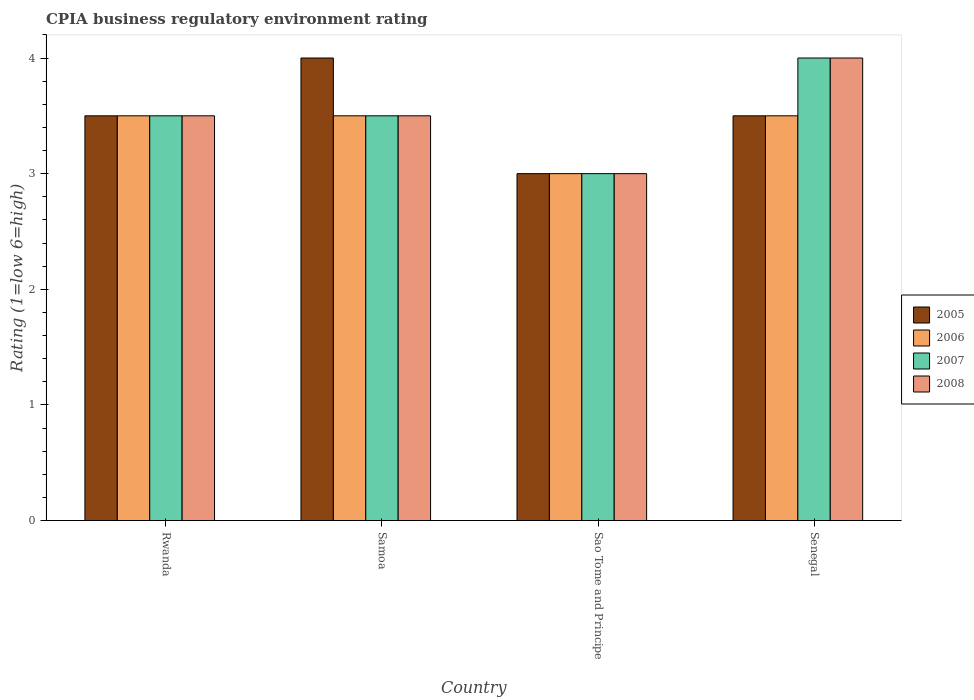How many groups of bars are there?
Your answer should be very brief. 4. What is the label of the 1st group of bars from the left?
Your response must be concise. Rwanda. Across all countries, what is the minimum CPIA rating in 2008?
Your response must be concise. 3. In which country was the CPIA rating in 2006 maximum?
Your answer should be very brief. Rwanda. In which country was the CPIA rating in 2007 minimum?
Your response must be concise. Sao Tome and Principe. What is the total CPIA rating in 2008 in the graph?
Provide a succinct answer. 14. What is the difference between the CPIA rating in 2007 in Sao Tome and Principe and the CPIA rating in 2008 in Samoa?
Provide a short and direct response. -0.5. What is the average CPIA rating in 2006 per country?
Keep it short and to the point. 3.38. What is the difference between the CPIA rating of/in 2007 and CPIA rating of/in 2005 in Senegal?
Give a very brief answer. 0.5. What is the difference between the highest and the second highest CPIA rating in 2005?
Offer a very short reply. -0.5. In how many countries, is the CPIA rating in 2008 greater than the average CPIA rating in 2008 taken over all countries?
Offer a terse response. 1. What does the 4th bar from the right in Sao Tome and Principe represents?
Ensure brevity in your answer.  2005. What is the difference between two consecutive major ticks on the Y-axis?
Your answer should be very brief. 1. Are the values on the major ticks of Y-axis written in scientific E-notation?
Keep it short and to the point. No. Where does the legend appear in the graph?
Your answer should be compact. Center right. How are the legend labels stacked?
Provide a succinct answer. Vertical. What is the title of the graph?
Ensure brevity in your answer.  CPIA business regulatory environment rating. Does "1995" appear as one of the legend labels in the graph?
Your answer should be compact. No. What is the Rating (1=low 6=high) in 2006 in Rwanda?
Your answer should be compact. 3.5. What is the Rating (1=low 6=high) of 2006 in Samoa?
Ensure brevity in your answer.  3.5. What is the Rating (1=low 6=high) in 2007 in Samoa?
Keep it short and to the point. 3.5. What is the Rating (1=low 6=high) of 2008 in Samoa?
Your answer should be very brief. 3.5. What is the Rating (1=low 6=high) of 2006 in Sao Tome and Principe?
Give a very brief answer. 3. What is the Rating (1=low 6=high) of 2007 in Sao Tome and Principe?
Offer a terse response. 3. What is the Rating (1=low 6=high) in 2006 in Senegal?
Give a very brief answer. 3.5. What is the Rating (1=low 6=high) of 2007 in Senegal?
Your answer should be compact. 4. What is the Rating (1=low 6=high) in 2008 in Senegal?
Offer a terse response. 4. Across all countries, what is the maximum Rating (1=low 6=high) in 2008?
Make the answer very short. 4. Across all countries, what is the minimum Rating (1=low 6=high) in 2006?
Provide a short and direct response. 3. Across all countries, what is the minimum Rating (1=low 6=high) in 2007?
Ensure brevity in your answer.  3. What is the total Rating (1=low 6=high) of 2005 in the graph?
Ensure brevity in your answer.  14. What is the total Rating (1=low 6=high) of 2006 in the graph?
Your answer should be compact. 13.5. What is the total Rating (1=low 6=high) of 2008 in the graph?
Offer a very short reply. 14. What is the difference between the Rating (1=low 6=high) in 2006 in Rwanda and that in Sao Tome and Principe?
Offer a very short reply. 0.5. What is the difference between the Rating (1=low 6=high) in 2008 in Rwanda and that in Sao Tome and Principe?
Your answer should be compact. 0.5. What is the difference between the Rating (1=low 6=high) in 2005 in Rwanda and that in Senegal?
Make the answer very short. 0. What is the difference between the Rating (1=low 6=high) in 2006 in Rwanda and that in Senegal?
Provide a short and direct response. 0. What is the difference between the Rating (1=low 6=high) in 2005 in Samoa and that in Sao Tome and Principe?
Your response must be concise. 1. What is the difference between the Rating (1=low 6=high) in 2007 in Samoa and that in Sao Tome and Principe?
Give a very brief answer. 0.5. What is the difference between the Rating (1=low 6=high) of 2008 in Samoa and that in Sao Tome and Principe?
Make the answer very short. 0.5. What is the difference between the Rating (1=low 6=high) of 2005 in Samoa and that in Senegal?
Offer a very short reply. 0.5. What is the difference between the Rating (1=low 6=high) of 2006 in Samoa and that in Senegal?
Ensure brevity in your answer.  0. What is the difference between the Rating (1=low 6=high) in 2007 in Samoa and that in Senegal?
Keep it short and to the point. -0.5. What is the difference between the Rating (1=low 6=high) in 2008 in Samoa and that in Senegal?
Make the answer very short. -0.5. What is the difference between the Rating (1=low 6=high) in 2005 in Sao Tome and Principe and that in Senegal?
Offer a terse response. -0.5. What is the difference between the Rating (1=low 6=high) in 2006 in Sao Tome and Principe and that in Senegal?
Provide a succinct answer. -0.5. What is the difference between the Rating (1=low 6=high) in 2008 in Sao Tome and Principe and that in Senegal?
Give a very brief answer. -1. What is the difference between the Rating (1=low 6=high) of 2007 in Rwanda and the Rating (1=low 6=high) of 2008 in Samoa?
Provide a short and direct response. 0. What is the difference between the Rating (1=low 6=high) of 2005 in Rwanda and the Rating (1=low 6=high) of 2006 in Sao Tome and Principe?
Keep it short and to the point. 0.5. What is the difference between the Rating (1=low 6=high) in 2005 in Rwanda and the Rating (1=low 6=high) in 2007 in Sao Tome and Principe?
Offer a very short reply. 0.5. What is the difference between the Rating (1=low 6=high) in 2005 in Rwanda and the Rating (1=low 6=high) in 2008 in Sao Tome and Principe?
Your answer should be very brief. 0.5. What is the difference between the Rating (1=low 6=high) in 2007 in Rwanda and the Rating (1=low 6=high) in 2008 in Sao Tome and Principe?
Make the answer very short. 0.5. What is the difference between the Rating (1=low 6=high) in 2006 in Rwanda and the Rating (1=low 6=high) in 2007 in Senegal?
Provide a short and direct response. -0.5. What is the difference between the Rating (1=low 6=high) in 2005 in Samoa and the Rating (1=low 6=high) in 2006 in Sao Tome and Principe?
Provide a succinct answer. 1. What is the difference between the Rating (1=low 6=high) in 2006 in Samoa and the Rating (1=low 6=high) in 2007 in Sao Tome and Principe?
Provide a short and direct response. 0.5. What is the difference between the Rating (1=low 6=high) in 2006 in Samoa and the Rating (1=low 6=high) in 2008 in Sao Tome and Principe?
Your answer should be compact. 0.5. What is the difference between the Rating (1=low 6=high) in 2007 in Samoa and the Rating (1=low 6=high) in 2008 in Sao Tome and Principe?
Offer a terse response. 0.5. What is the difference between the Rating (1=low 6=high) of 2005 in Samoa and the Rating (1=low 6=high) of 2006 in Senegal?
Provide a short and direct response. 0.5. What is the difference between the Rating (1=low 6=high) in 2005 in Samoa and the Rating (1=low 6=high) in 2007 in Senegal?
Your answer should be compact. 0. What is the difference between the Rating (1=low 6=high) of 2005 in Samoa and the Rating (1=low 6=high) of 2008 in Senegal?
Provide a short and direct response. 0. What is the difference between the Rating (1=low 6=high) of 2006 in Samoa and the Rating (1=low 6=high) of 2007 in Senegal?
Keep it short and to the point. -0.5. What is the difference between the Rating (1=low 6=high) in 2006 in Samoa and the Rating (1=low 6=high) in 2008 in Senegal?
Offer a very short reply. -0.5. What is the difference between the Rating (1=low 6=high) of 2005 in Sao Tome and Principe and the Rating (1=low 6=high) of 2006 in Senegal?
Ensure brevity in your answer.  -0.5. What is the difference between the Rating (1=low 6=high) in 2005 in Sao Tome and Principe and the Rating (1=low 6=high) in 2007 in Senegal?
Your answer should be compact. -1. What is the difference between the Rating (1=low 6=high) of 2005 in Sao Tome and Principe and the Rating (1=low 6=high) of 2008 in Senegal?
Offer a terse response. -1. What is the difference between the Rating (1=low 6=high) in 2006 in Sao Tome and Principe and the Rating (1=low 6=high) in 2007 in Senegal?
Ensure brevity in your answer.  -1. What is the difference between the Rating (1=low 6=high) in 2007 in Sao Tome and Principe and the Rating (1=low 6=high) in 2008 in Senegal?
Offer a very short reply. -1. What is the average Rating (1=low 6=high) in 2005 per country?
Your response must be concise. 3.5. What is the average Rating (1=low 6=high) of 2006 per country?
Give a very brief answer. 3.38. What is the average Rating (1=low 6=high) of 2007 per country?
Ensure brevity in your answer.  3.5. What is the average Rating (1=low 6=high) of 2008 per country?
Your answer should be compact. 3.5. What is the difference between the Rating (1=low 6=high) in 2005 and Rating (1=low 6=high) in 2006 in Rwanda?
Your answer should be very brief. 0. What is the difference between the Rating (1=low 6=high) in 2005 and Rating (1=low 6=high) in 2007 in Rwanda?
Make the answer very short. 0. What is the difference between the Rating (1=low 6=high) of 2005 and Rating (1=low 6=high) of 2008 in Rwanda?
Provide a succinct answer. 0. What is the difference between the Rating (1=low 6=high) in 2006 and Rating (1=low 6=high) in 2008 in Rwanda?
Ensure brevity in your answer.  0. What is the difference between the Rating (1=low 6=high) in 2005 and Rating (1=low 6=high) in 2007 in Samoa?
Offer a terse response. 0.5. What is the difference between the Rating (1=low 6=high) of 2006 and Rating (1=low 6=high) of 2007 in Samoa?
Your response must be concise. 0. What is the difference between the Rating (1=low 6=high) in 2007 and Rating (1=low 6=high) in 2008 in Samoa?
Ensure brevity in your answer.  0. What is the difference between the Rating (1=low 6=high) of 2005 and Rating (1=low 6=high) of 2007 in Sao Tome and Principe?
Offer a very short reply. 0. What is the difference between the Rating (1=low 6=high) in 2007 and Rating (1=low 6=high) in 2008 in Sao Tome and Principe?
Ensure brevity in your answer.  0. What is the ratio of the Rating (1=low 6=high) of 2005 in Rwanda to that in Samoa?
Offer a terse response. 0.88. What is the ratio of the Rating (1=low 6=high) of 2006 in Rwanda to that in Samoa?
Your answer should be very brief. 1. What is the ratio of the Rating (1=low 6=high) in 2007 in Rwanda to that in Samoa?
Offer a very short reply. 1. What is the ratio of the Rating (1=low 6=high) in 2008 in Rwanda to that in Samoa?
Provide a short and direct response. 1. What is the ratio of the Rating (1=low 6=high) in 2006 in Rwanda to that in Sao Tome and Principe?
Your answer should be compact. 1.17. What is the ratio of the Rating (1=low 6=high) of 2007 in Rwanda to that in Sao Tome and Principe?
Ensure brevity in your answer.  1.17. What is the ratio of the Rating (1=low 6=high) in 2005 in Rwanda to that in Senegal?
Your answer should be compact. 1. What is the ratio of the Rating (1=low 6=high) of 2006 in Rwanda to that in Senegal?
Ensure brevity in your answer.  1. What is the ratio of the Rating (1=low 6=high) in 2008 in Rwanda to that in Senegal?
Offer a very short reply. 0.88. What is the ratio of the Rating (1=low 6=high) of 2006 in Samoa to that in Sao Tome and Principe?
Make the answer very short. 1.17. What is the ratio of the Rating (1=low 6=high) in 2006 in Samoa to that in Senegal?
Your answer should be compact. 1. What is the ratio of the Rating (1=low 6=high) of 2008 in Samoa to that in Senegal?
Your answer should be compact. 0.88. What is the ratio of the Rating (1=low 6=high) of 2006 in Sao Tome and Principe to that in Senegal?
Your answer should be very brief. 0.86. What is the ratio of the Rating (1=low 6=high) of 2008 in Sao Tome and Principe to that in Senegal?
Provide a short and direct response. 0.75. What is the difference between the highest and the second highest Rating (1=low 6=high) in 2006?
Offer a terse response. 0. What is the difference between the highest and the lowest Rating (1=low 6=high) in 2005?
Your answer should be very brief. 1. 